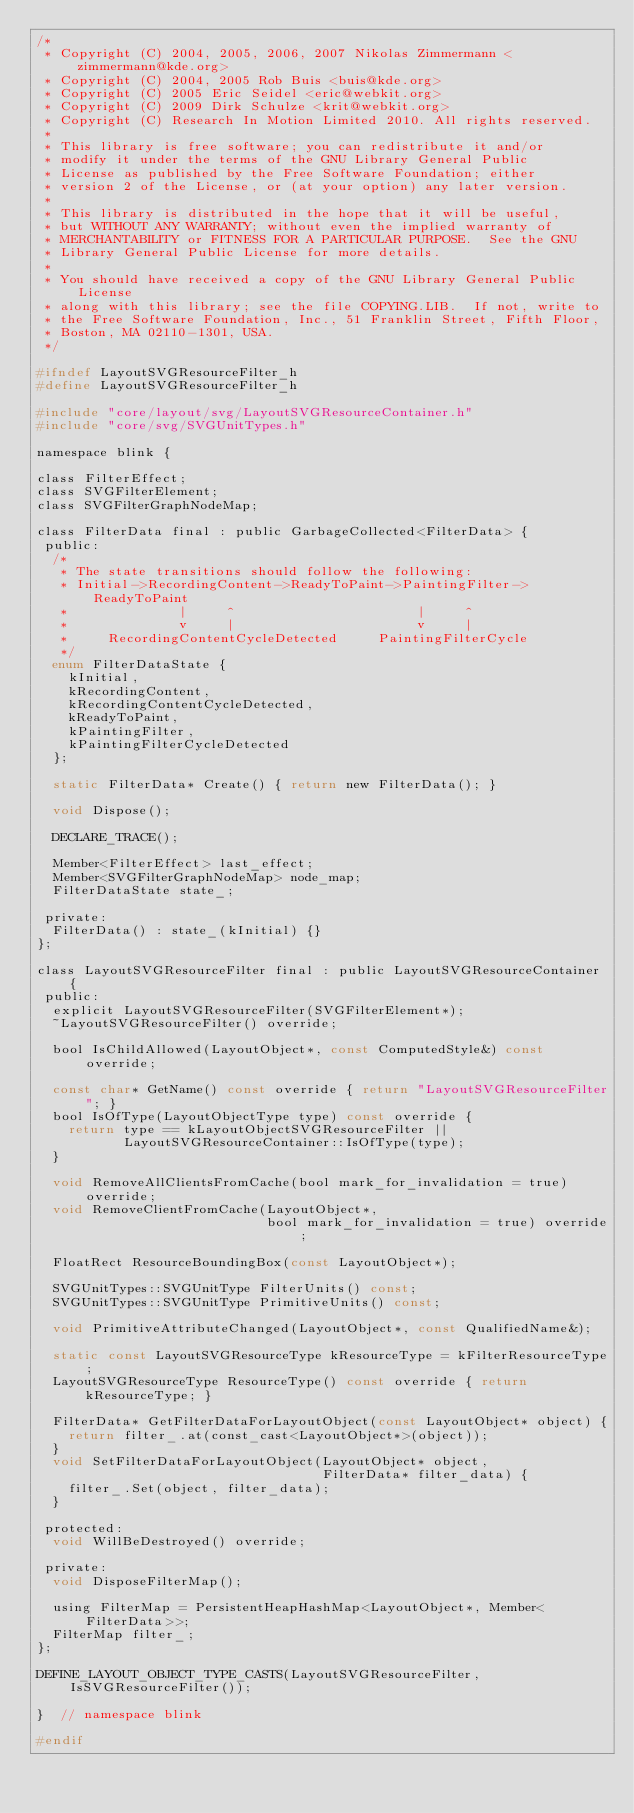Convert code to text. <code><loc_0><loc_0><loc_500><loc_500><_C_>/*
 * Copyright (C) 2004, 2005, 2006, 2007 Nikolas Zimmermann <zimmermann@kde.org>
 * Copyright (C) 2004, 2005 Rob Buis <buis@kde.org>
 * Copyright (C) 2005 Eric Seidel <eric@webkit.org>
 * Copyright (C) 2009 Dirk Schulze <krit@webkit.org>
 * Copyright (C) Research In Motion Limited 2010. All rights reserved.
 *
 * This library is free software; you can redistribute it and/or
 * modify it under the terms of the GNU Library General Public
 * License as published by the Free Software Foundation; either
 * version 2 of the License, or (at your option) any later version.
 *
 * This library is distributed in the hope that it will be useful,
 * but WITHOUT ANY WARRANTY; without even the implied warranty of
 * MERCHANTABILITY or FITNESS FOR A PARTICULAR PURPOSE.  See the GNU
 * Library General Public License for more details.
 *
 * You should have received a copy of the GNU Library General Public License
 * along with this library; see the file COPYING.LIB.  If not, write to
 * the Free Software Foundation, Inc., 51 Franklin Street, Fifth Floor,
 * Boston, MA 02110-1301, USA.
 */

#ifndef LayoutSVGResourceFilter_h
#define LayoutSVGResourceFilter_h

#include "core/layout/svg/LayoutSVGResourceContainer.h"
#include "core/svg/SVGUnitTypes.h"

namespace blink {

class FilterEffect;
class SVGFilterElement;
class SVGFilterGraphNodeMap;

class FilterData final : public GarbageCollected<FilterData> {
 public:
  /*
   * The state transitions should follow the following:
   * Initial->RecordingContent->ReadyToPaint->PaintingFilter->ReadyToPaint
   *              |     ^                       |     ^
   *              v     |                       v     |
   *     RecordingContentCycleDetected     PaintingFilterCycle
   */
  enum FilterDataState {
    kInitial,
    kRecordingContent,
    kRecordingContentCycleDetected,
    kReadyToPaint,
    kPaintingFilter,
    kPaintingFilterCycleDetected
  };

  static FilterData* Create() { return new FilterData(); }

  void Dispose();

  DECLARE_TRACE();

  Member<FilterEffect> last_effect;
  Member<SVGFilterGraphNodeMap> node_map;
  FilterDataState state_;

 private:
  FilterData() : state_(kInitial) {}
};

class LayoutSVGResourceFilter final : public LayoutSVGResourceContainer {
 public:
  explicit LayoutSVGResourceFilter(SVGFilterElement*);
  ~LayoutSVGResourceFilter() override;

  bool IsChildAllowed(LayoutObject*, const ComputedStyle&) const override;

  const char* GetName() const override { return "LayoutSVGResourceFilter"; }
  bool IsOfType(LayoutObjectType type) const override {
    return type == kLayoutObjectSVGResourceFilter ||
           LayoutSVGResourceContainer::IsOfType(type);
  }

  void RemoveAllClientsFromCache(bool mark_for_invalidation = true) override;
  void RemoveClientFromCache(LayoutObject*,
                             bool mark_for_invalidation = true) override;

  FloatRect ResourceBoundingBox(const LayoutObject*);

  SVGUnitTypes::SVGUnitType FilterUnits() const;
  SVGUnitTypes::SVGUnitType PrimitiveUnits() const;

  void PrimitiveAttributeChanged(LayoutObject*, const QualifiedName&);

  static const LayoutSVGResourceType kResourceType = kFilterResourceType;
  LayoutSVGResourceType ResourceType() const override { return kResourceType; }

  FilterData* GetFilterDataForLayoutObject(const LayoutObject* object) {
    return filter_.at(const_cast<LayoutObject*>(object));
  }
  void SetFilterDataForLayoutObject(LayoutObject* object,
                                    FilterData* filter_data) {
    filter_.Set(object, filter_data);
  }

 protected:
  void WillBeDestroyed() override;

 private:
  void DisposeFilterMap();

  using FilterMap = PersistentHeapHashMap<LayoutObject*, Member<FilterData>>;
  FilterMap filter_;
};

DEFINE_LAYOUT_OBJECT_TYPE_CASTS(LayoutSVGResourceFilter, IsSVGResourceFilter());

}  // namespace blink

#endif
</code> 